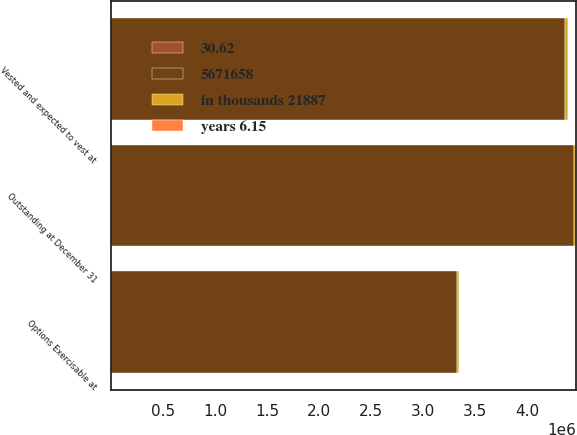Convert chart. <chart><loc_0><loc_0><loc_500><loc_500><stacked_bar_chart><ecel><fcel>Outstanding at December 31<fcel>Vested and expected to vest at<fcel>Options Exercisable at<nl><fcel>5671658<fcel>4.44877e+06<fcel>4.36747e+06<fcel>3.32934e+06<nl><fcel>30.62<fcel>33.56<fcel>33.54<fcel>36.24<nl><fcel>years 6.15<fcel>4.55<fcel>4.5<fcel>3.83<nl><fcel>in thousands 21887<fcel>25522<fcel>25113<fcel>12565<nl></chart> 